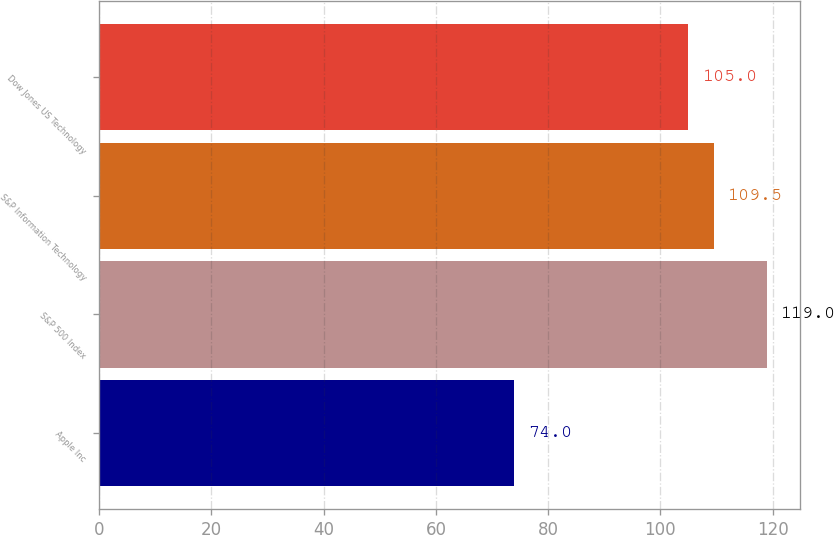Convert chart to OTSL. <chart><loc_0><loc_0><loc_500><loc_500><bar_chart><fcel>Apple Inc<fcel>S&P 500 Index<fcel>S&P Information Technology<fcel>Dow Jones US Technology<nl><fcel>74<fcel>119<fcel>109.5<fcel>105<nl></chart> 